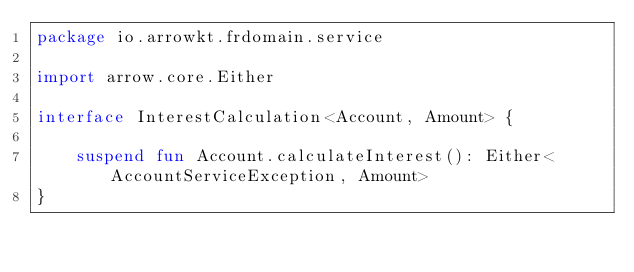<code> <loc_0><loc_0><loc_500><loc_500><_Kotlin_>package io.arrowkt.frdomain.service

import arrow.core.Either

interface InterestCalculation<Account, Amount> {

    suspend fun Account.calculateInterest(): Either<AccountServiceException, Amount>
}</code> 